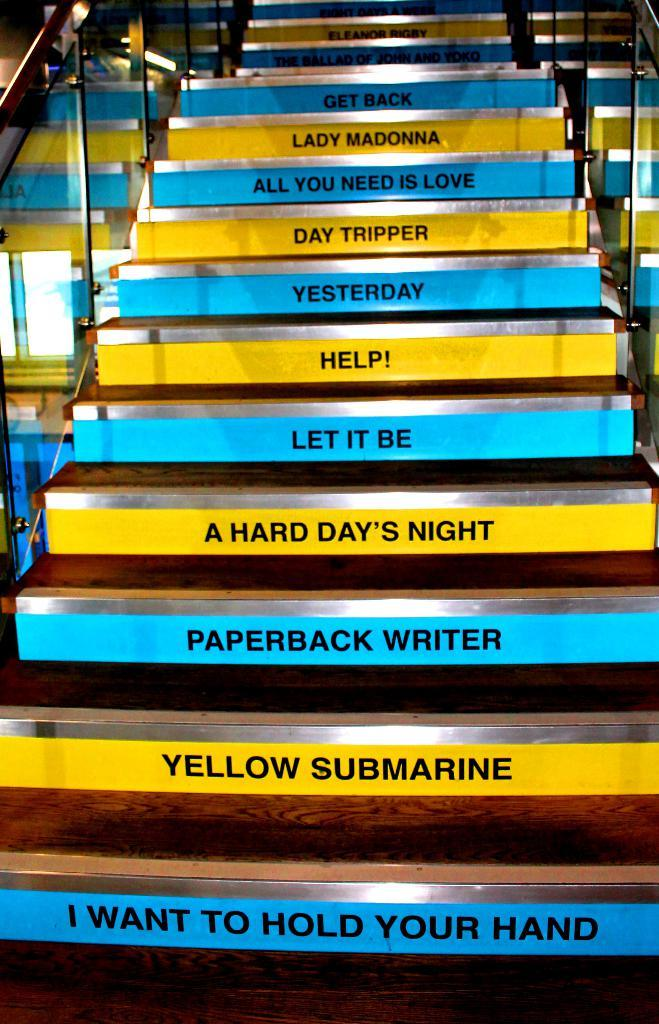Provide a one-sentence caption for the provided image. Different Beatle song titles decorate the steps of a wood, glass and chrome staircase. 